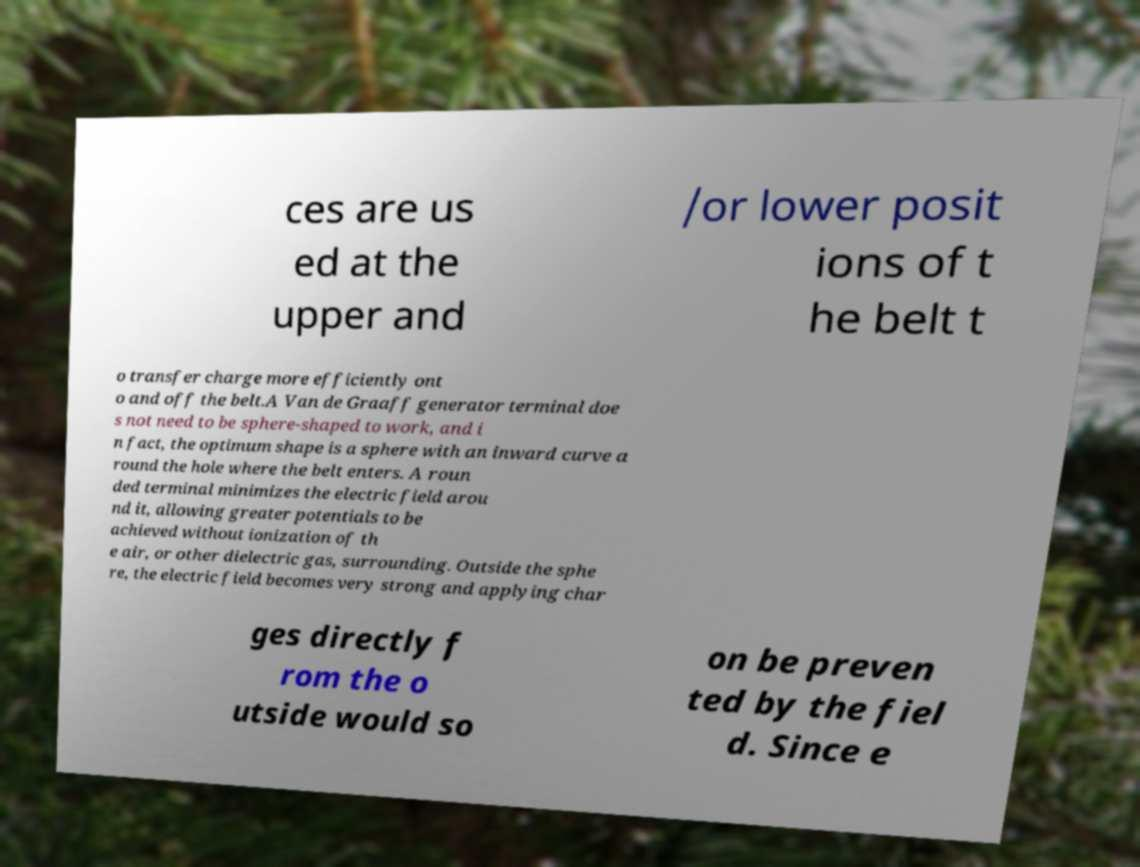What messages or text are displayed in this image? I need them in a readable, typed format. ces are us ed at the upper and /or lower posit ions of t he belt t o transfer charge more efficiently ont o and off the belt.A Van de Graaff generator terminal doe s not need to be sphere-shaped to work, and i n fact, the optimum shape is a sphere with an inward curve a round the hole where the belt enters. A roun ded terminal minimizes the electric field arou nd it, allowing greater potentials to be achieved without ionization of th e air, or other dielectric gas, surrounding. Outside the sphe re, the electric field becomes very strong and applying char ges directly f rom the o utside would so on be preven ted by the fiel d. Since e 